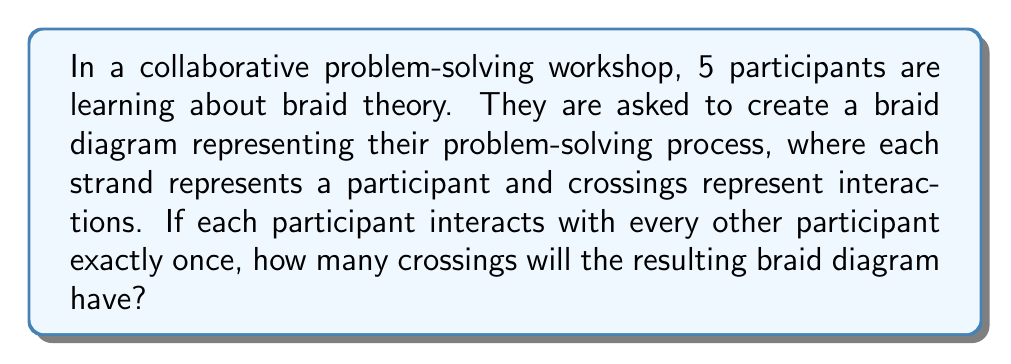Solve this math problem. Let's approach this step-by-step:

1) In braid theory, crossings represent interactions between strands. In this case, each crossing represents an interaction between two participants.

2) We need to determine how many unique interactions occur when each participant interacts with every other participant exactly once.

3) This is equivalent to choosing 2 participants from 5, where the order doesn't matter (as A interacting with B is the same as B interacting with A).

4) This is a combination problem, represented by $\binom{5}{2}$ or $C(5,2)$.

5) The formula for this combination is:

   $$\binom{5}{2} = \frac{5!}{2!(5-2)!} = \frac{5!}{2!(3)!}$$

6) Expanding this:
   
   $$\frac{5 \cdot 4 \cdot 3!}{2 \cdot 1 \cdot 3!} = \frac{20}{2} = 10$$

7) Therefore, there will be 10 unique interactions, which means 10 crossings in the braid diagram.

This braid representation encourages participants to visualize their collaborative process, fostering awareness of team dynamics and promoting effective problem-solving skills.
Answer: 10 crossings 